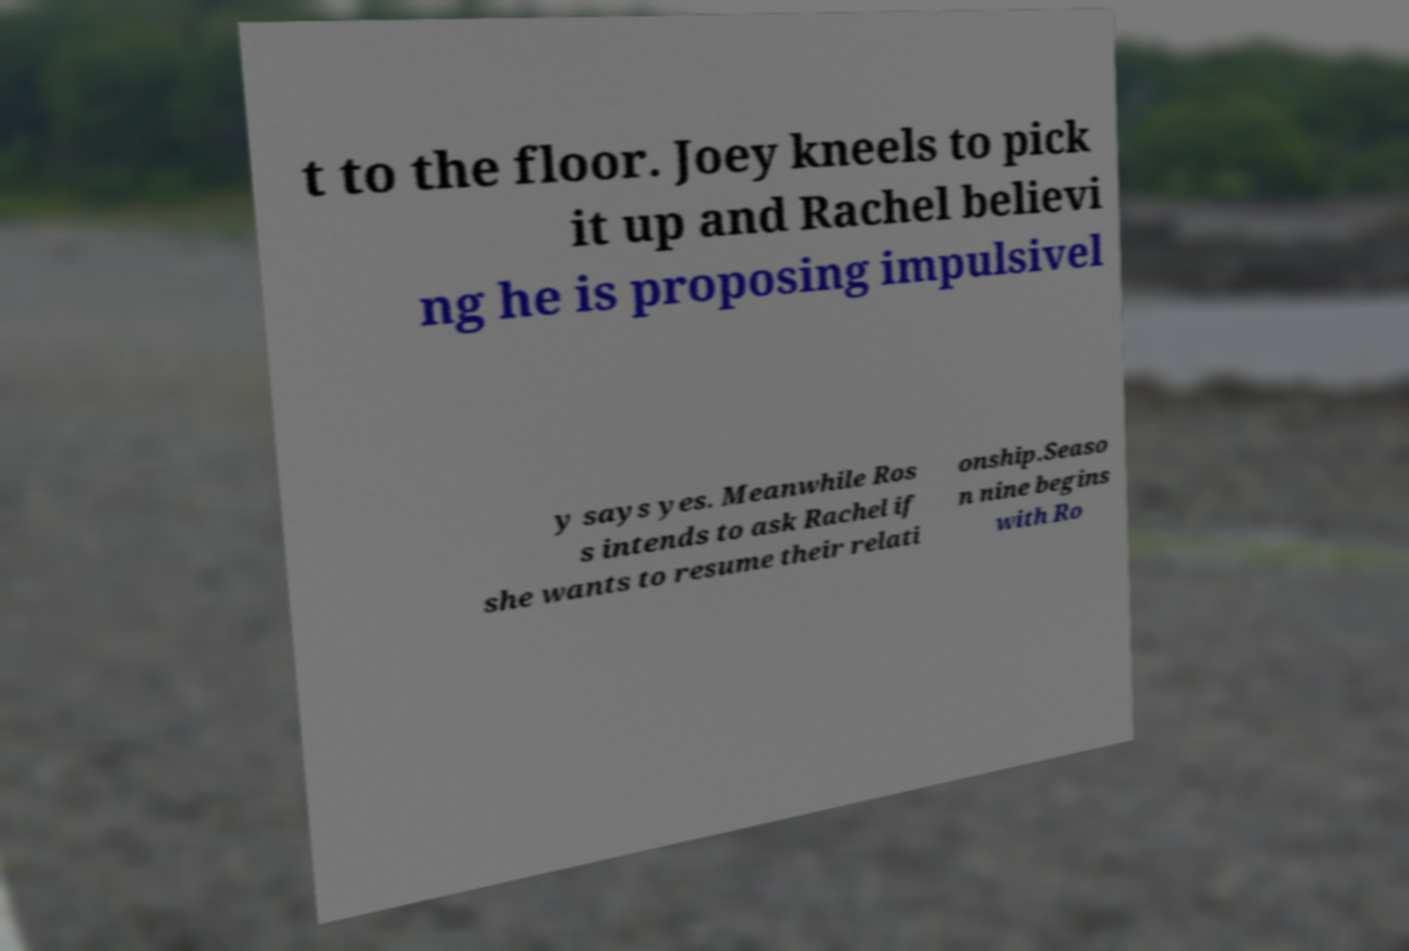I need the written content from this picture converted into text. Can you do that? t to the floor. Joey kneels to pick it up and Rachel believi ng he is proposing impulsivel y says yes. Meanwhile Ros s intends to ask Rachel if she wants to resume their relati onship.Seaso n nine begins with Ro 